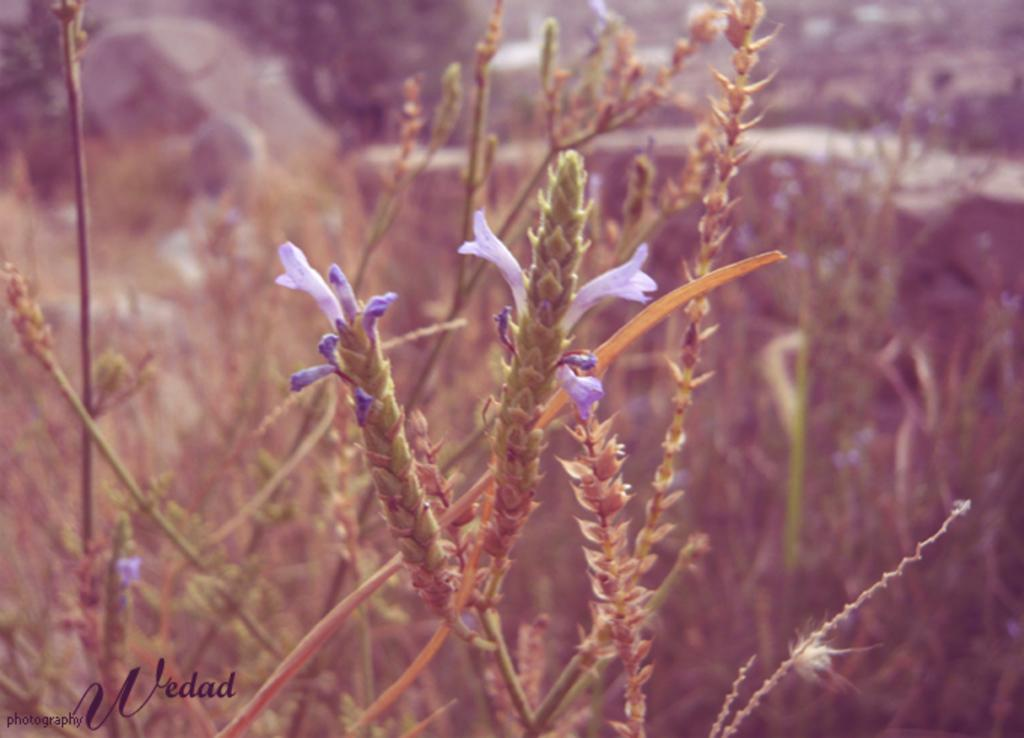What type of flowers can be seen in the image? There are purple color flowers in the image. What else is present in the image besides the flowers? There are plants in the image. Can you describe the background of the image? The background of the image is blurred. What type of lettuce is being used to express an opinion in the image? There is no lettuce present in the image, and no opinions are being expressed. 